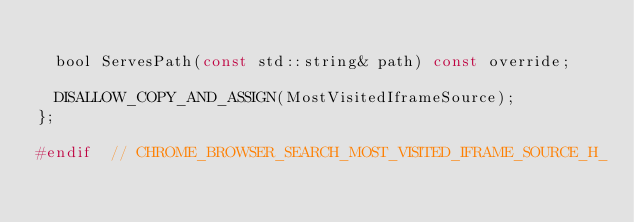<code> <loc_0><loc_0><loc_500><loc_500><_C_>
  bool ServesPath(const std::string& path) const override;

  DISALLOW_COPY_AND_ASSIGN(MostVisitedIframeSource);
};

#endif  // CHROME_BROWSER_SEARCH_MOST_VISITED_IFRAME_SOURCE_H_
</code> 